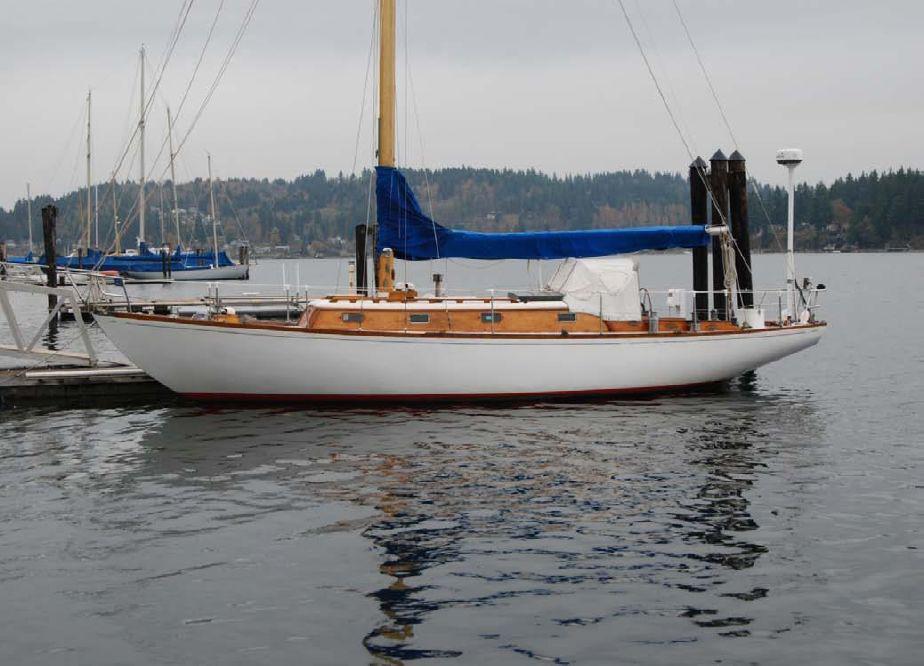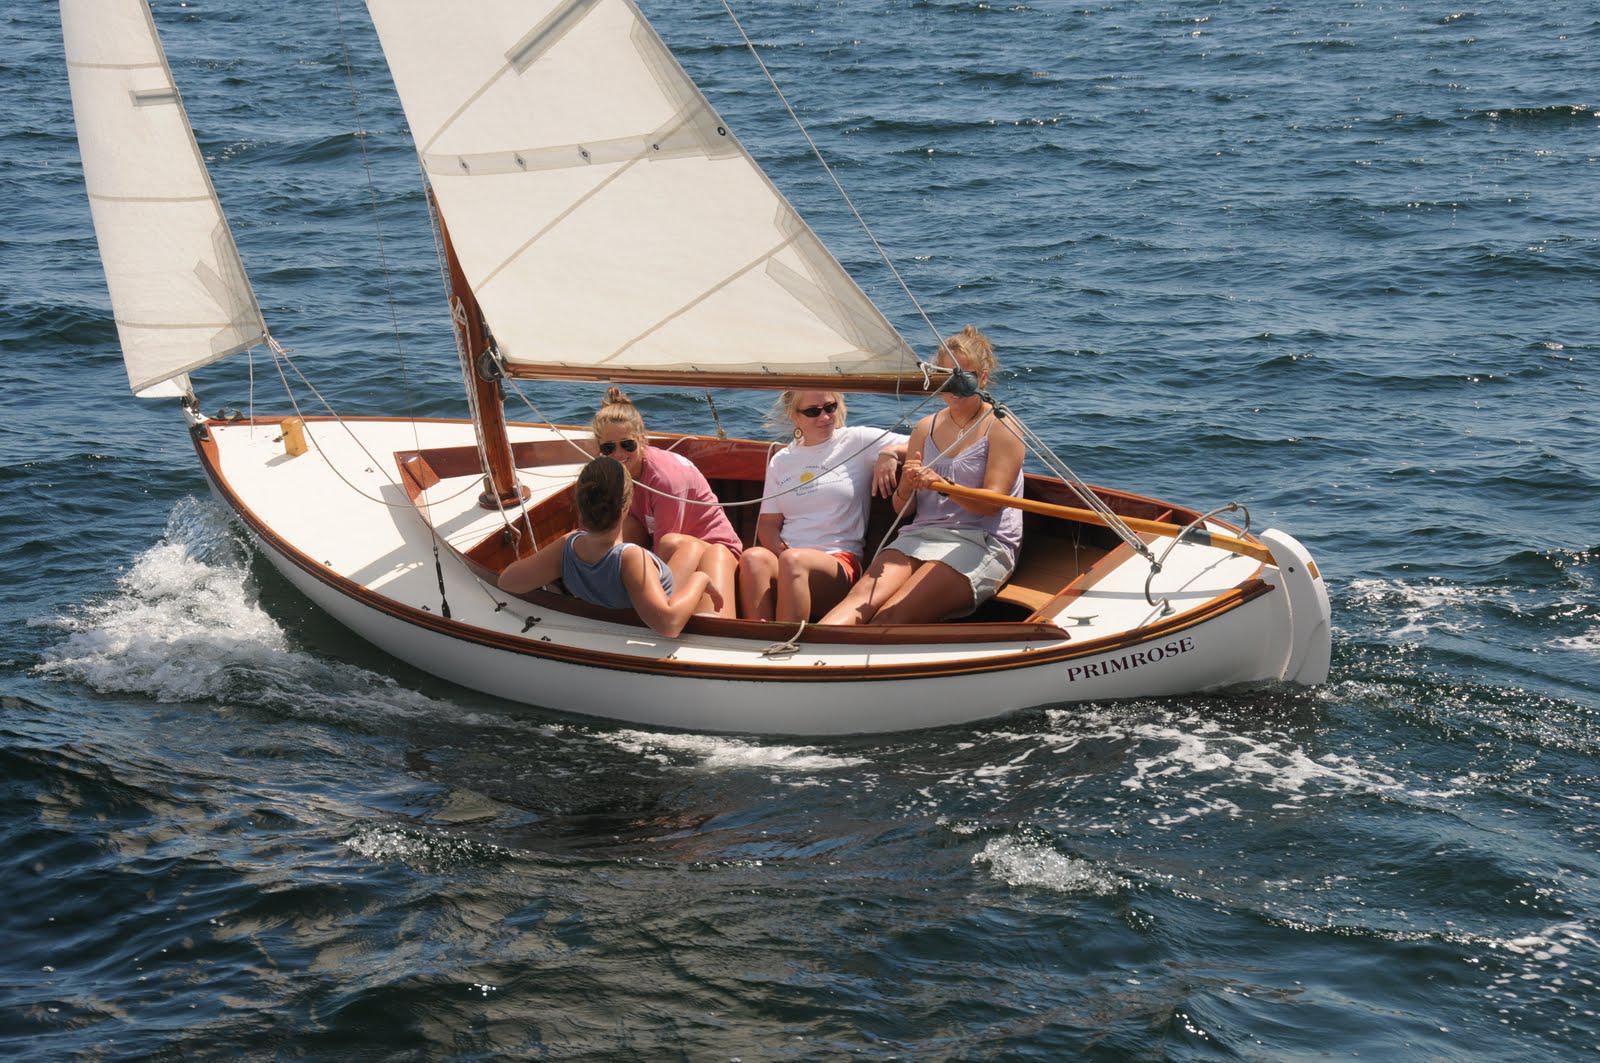The first image is the image on the left, the second image is the image on the right. Examine the images to the left and right. Is the description "The boat in the image on the left has no sails up." accurate? Answer yes or no. Yes. The first image is the image on the left, the second image is the image on the right. Analyze the images presented: Is the assertion "The boat in the left image has furled sails, while the boat on the right is moving and creating white spray." valid? Answer yes or no. Yes. 